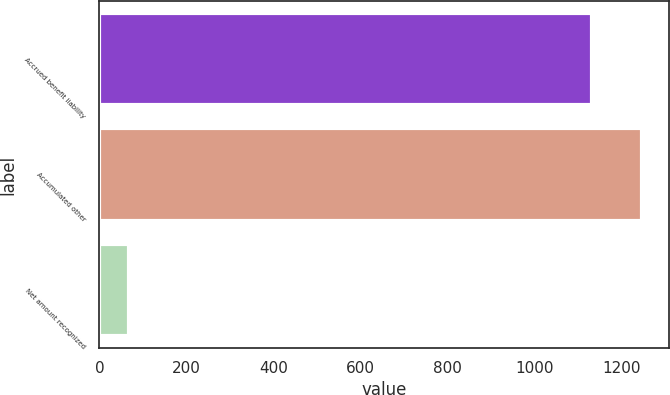Convert chart to OTSL. <chart><loc_0><loc_0><loc_500><loc_500><bar_chart><fcel>Accrued benefit liability<fcel>Accumulated other<fcel>Net amount recognized<nl><fcel>1132<fcel>1245.2<fcel>68<nl></chart> 